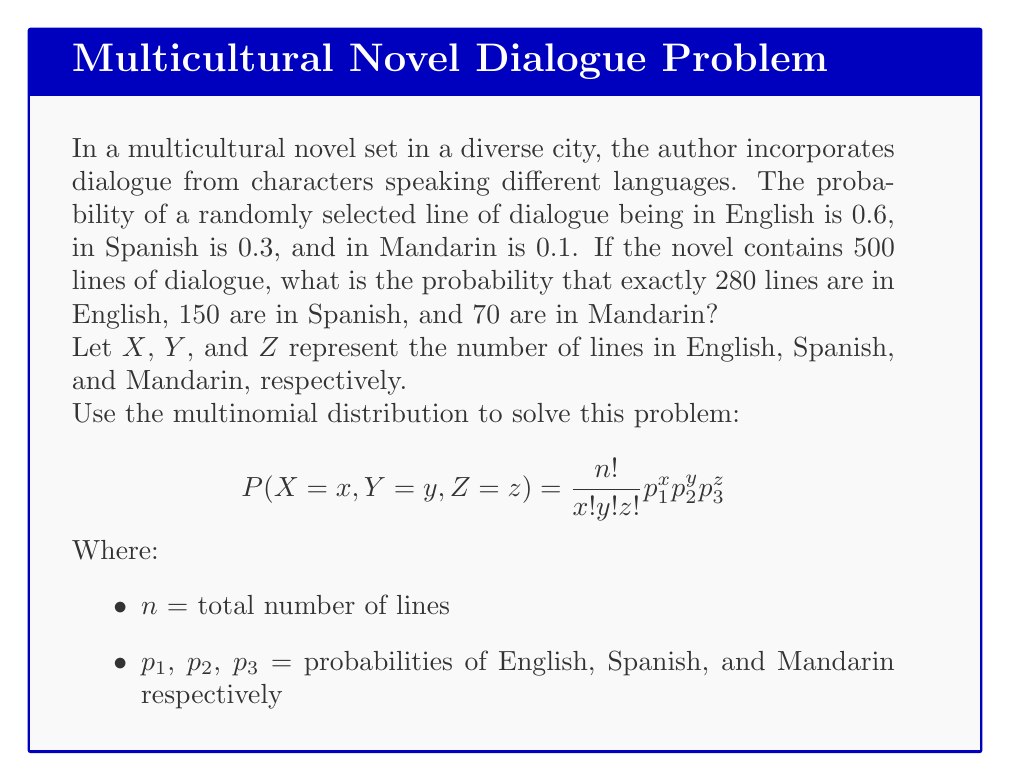Give your solution to this math problem. To solve this problem, we'll use the multinomial distribution formula:

$$P(X=x, Y=y, Z=z) = \frac{n!}{x!y!z!} p_1^x p_2^y p_3^z$$

Given:
- n = 500 (total lines of dialogue)
- x = 280 (English lines)
- y = 150 (Spanish lines)
- z = 70 (Mandarin lines)
- $p_1 = 0.6$ (probability of English)
- $p_2 = 0.3$ (probability of Spanish)
- $p_3 = 0.1$ (probability of Mandarin)

Step 1: Calculate the factorial terms:
500! / (280! * 150! * 70!)

Step 2: Calculate the probability terms:
$0.6^{280} * 0.3^{150} * 0.1^{70}$

Step 3: Multiply the results from steps 1 and 2:

$$P(X=280, Y=150, Z=70) = \frac{500!}{280!150!70!} * 0.6^{280} * 0.3^{150} * 0.1^{70}$$

Step 4: Use a calculator or computer to evaluate this expression, as the numbers are very large.

The result is approximately 0.0282 or 2.82%.
Answer: 0.0282 (or 2.82%) 